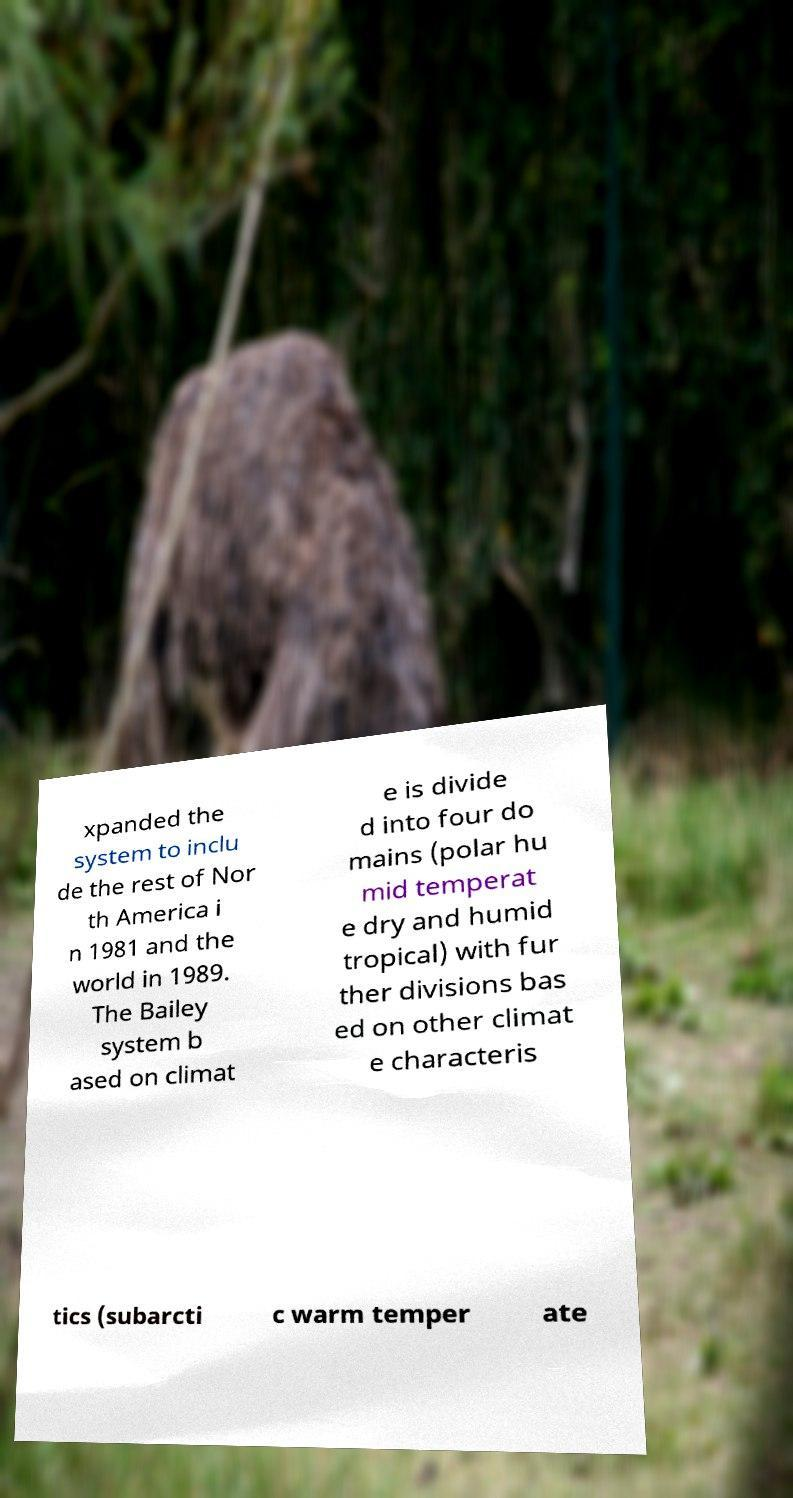What messages or text are displayed in this image? I need them in a readable, typed format. xpanded the system to inclu de the rest of Nor th America i n 1981 and the world in 1989. The Bailey system b ased on climat e is divide d into four do mains (polar hu mid temperat e dry and humid tropical) with fur ther divisions bas ed on other climat e characteris tics (subarcti c warm temper ate 